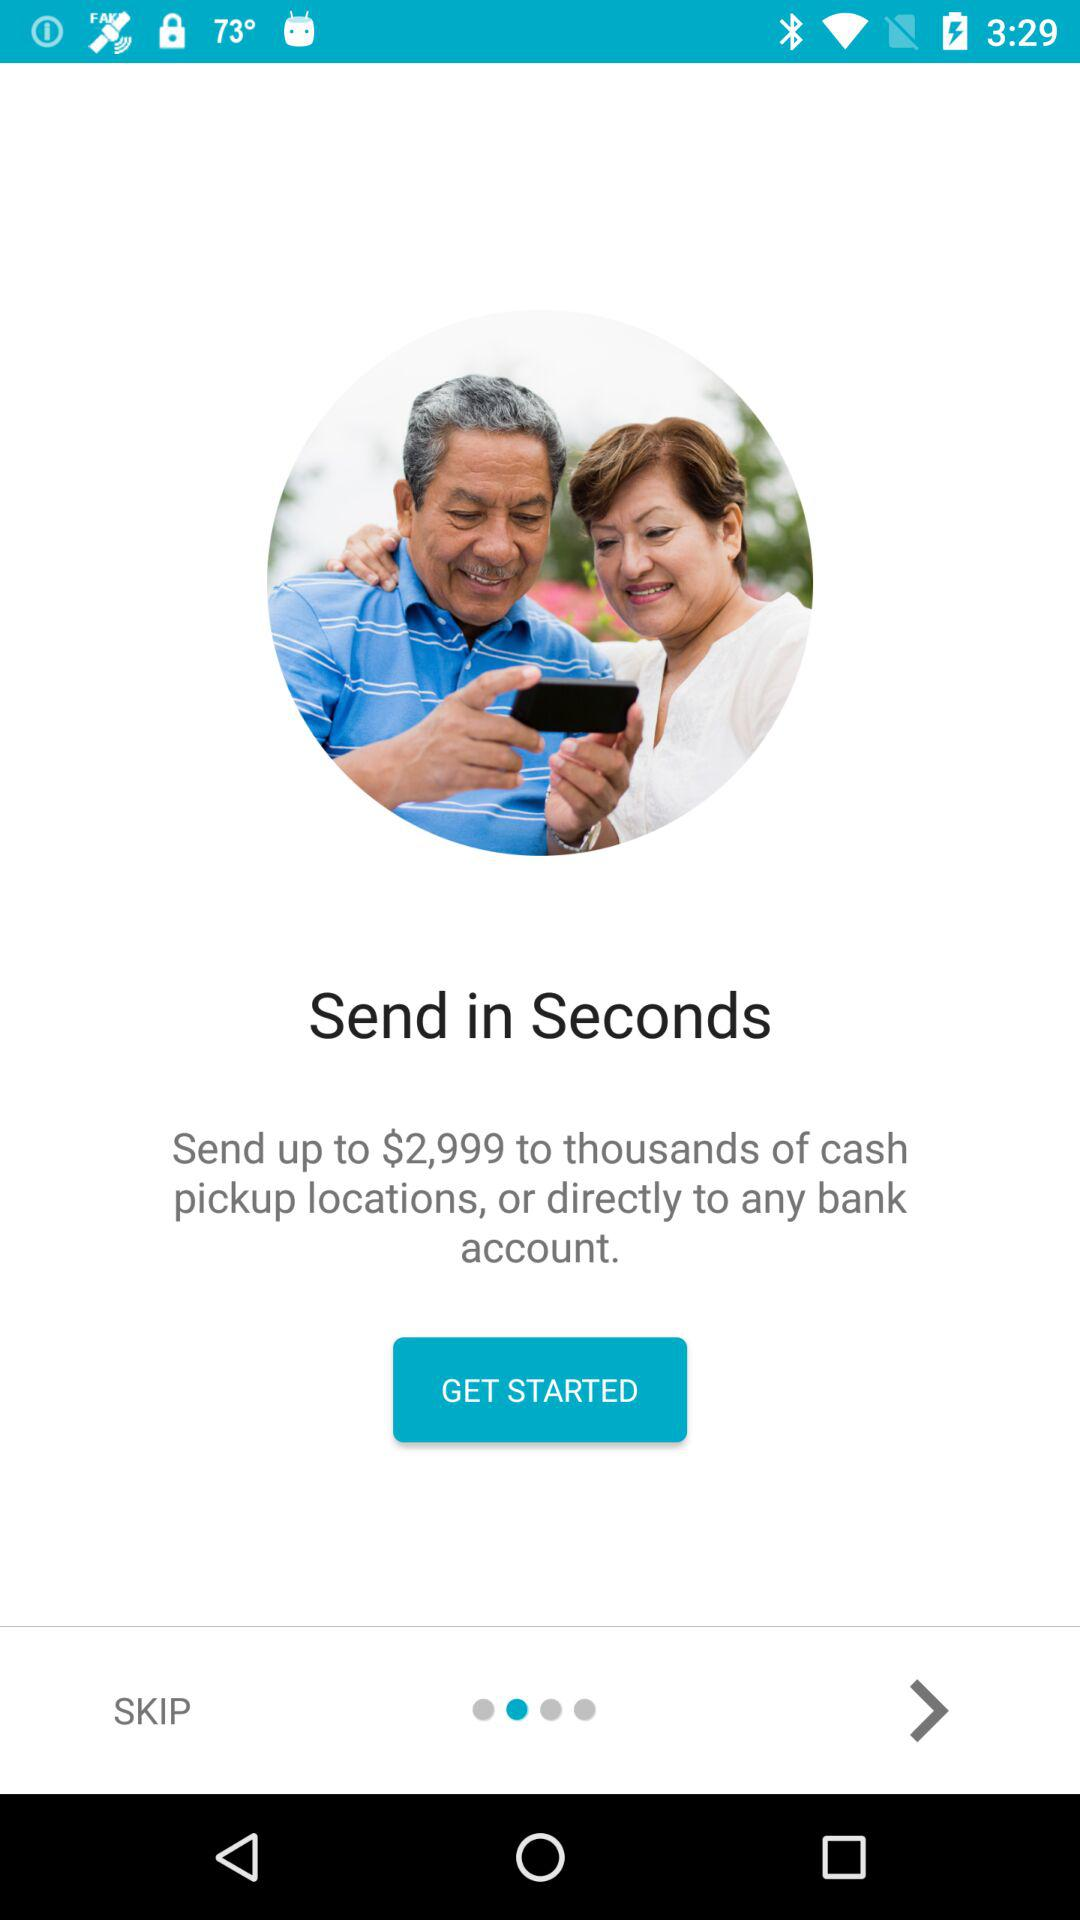How much amount can be sent to thousands of locations or directly to a bank account? The amount is up to $2,999. 